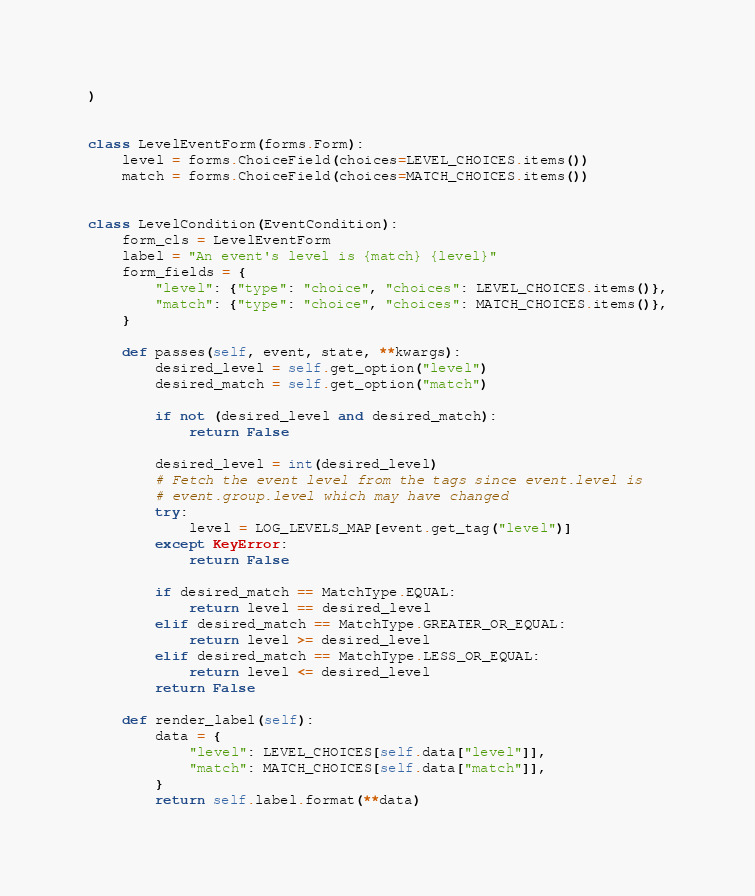Convert code to text. <code><loc_0><loc_0><loc_500><loc_500><_Python_>)


class LevelEventForm(forms.Form):
    level = forms.ChoiceField(choices=LEVEL_CHOICES.items())
    match = forms.ChoiceField(choices=MATCH_CHOICES.items())


class LevelCondition(EventCondition):
    form_cls = LevelEventForm
    label = "An event's level is {match} {level}"
    form_fields = {
        "level": {"type": "choice", "choices": LEVEL_CHOICES.items()},
        "match": {"type": "choice", "choices": MATCH_CHOICES.items()},
    }

    def passes(self, event, state, **kwargs):
        desired_level = self.get_option("level")
        desired_match = self.get_option("match")

        if not (desired_level and desired_match):
            return False

        desired_level = int(desired_level)
        # Fetch the event level from the tags since event.level is
        # event.group.level which may have changed
        try:
            level = LOG_LEVELS_MAP[event.get_tag("level")]
        except KeyError:
            return False

        if desired_match == MatchType.EQUAL:
            return level == desired_level
        elif desired_match == MatchType.GREATER_OR_EQUAL:
            return level >= desired_level
        elif desired_match == MatchType.LESS_OR_EQUAL:
            return level <= desired_level
        return False

    def render_label(self):
        data = {
            "level": LEVEL_CHOICES[self.data["level"]],
            "match": MATCH_CHOICES[self.data["match"]],
        }
        return self.label.format(**data)
</code> 